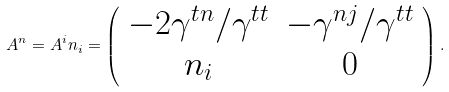Convert formula to latex. <formula><loc_0><loc_0><loc_500><loc_500>A ^ { n } = A ^ { i } n _ { i } = \left ( \begin{array} { c c } - 2 \gamma ^ { t n } / \gamma ^ { t t } & - \gamma ^ { n j } / \gamma ^ { t t } \\ n _ { i } & 0 \end{array} \right ) .</formula> 